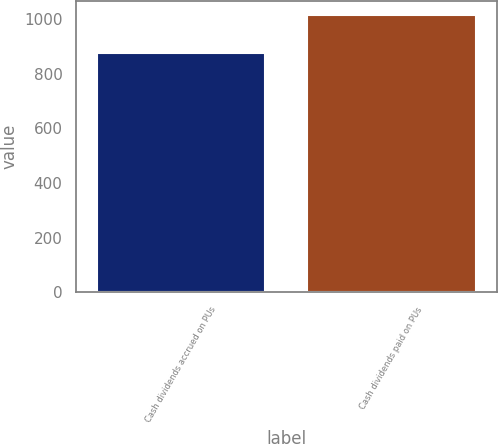<chart> <loc_0><loc_0><loc_500><loc_500><bar_chart><fcel>Cash dividends accrued on PUs<fcel>Cash dividends paid on PUs<nl><fcel>874<fcel>1015<nl></chart> 